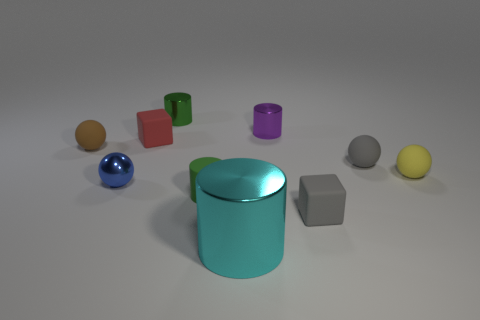Subtract all yellow spheres. How many spheres are left? 3 Subtract all large cylinders. How many cylinders are left? 3 Subtract all green spheres. Subtract all brown cubes. How many spheres are left? 4 Subtract all cylinders. How many objects are left? 6 Add 7 tiny green cylinders. How many tiny green cylinders are left? 9 Add 4 tiny red matte cubes. How many tiny red matte cubes exist? 5 Subtract 0 cyan spheres. How many objects are left? 10 Subtract all tiny purple metal objects. Subtract all purple metallic objects. How many objects are left? 8 